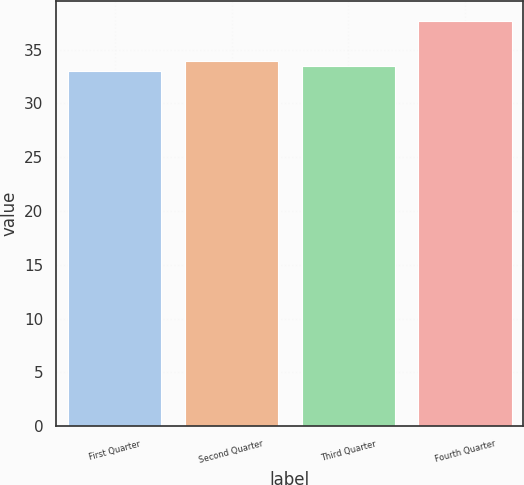Convert chart. <chart><loc_0><loc_0><loc_500><loc_500><bar_chart><fcel>First Quarter<fcel>Second Quarter<fcel>Third Quarter<fcel>Fourth Quarter<nl><fcel>33.03<fcel>33.97<fcel>33.5<fcel>37.68<nl></chart> 